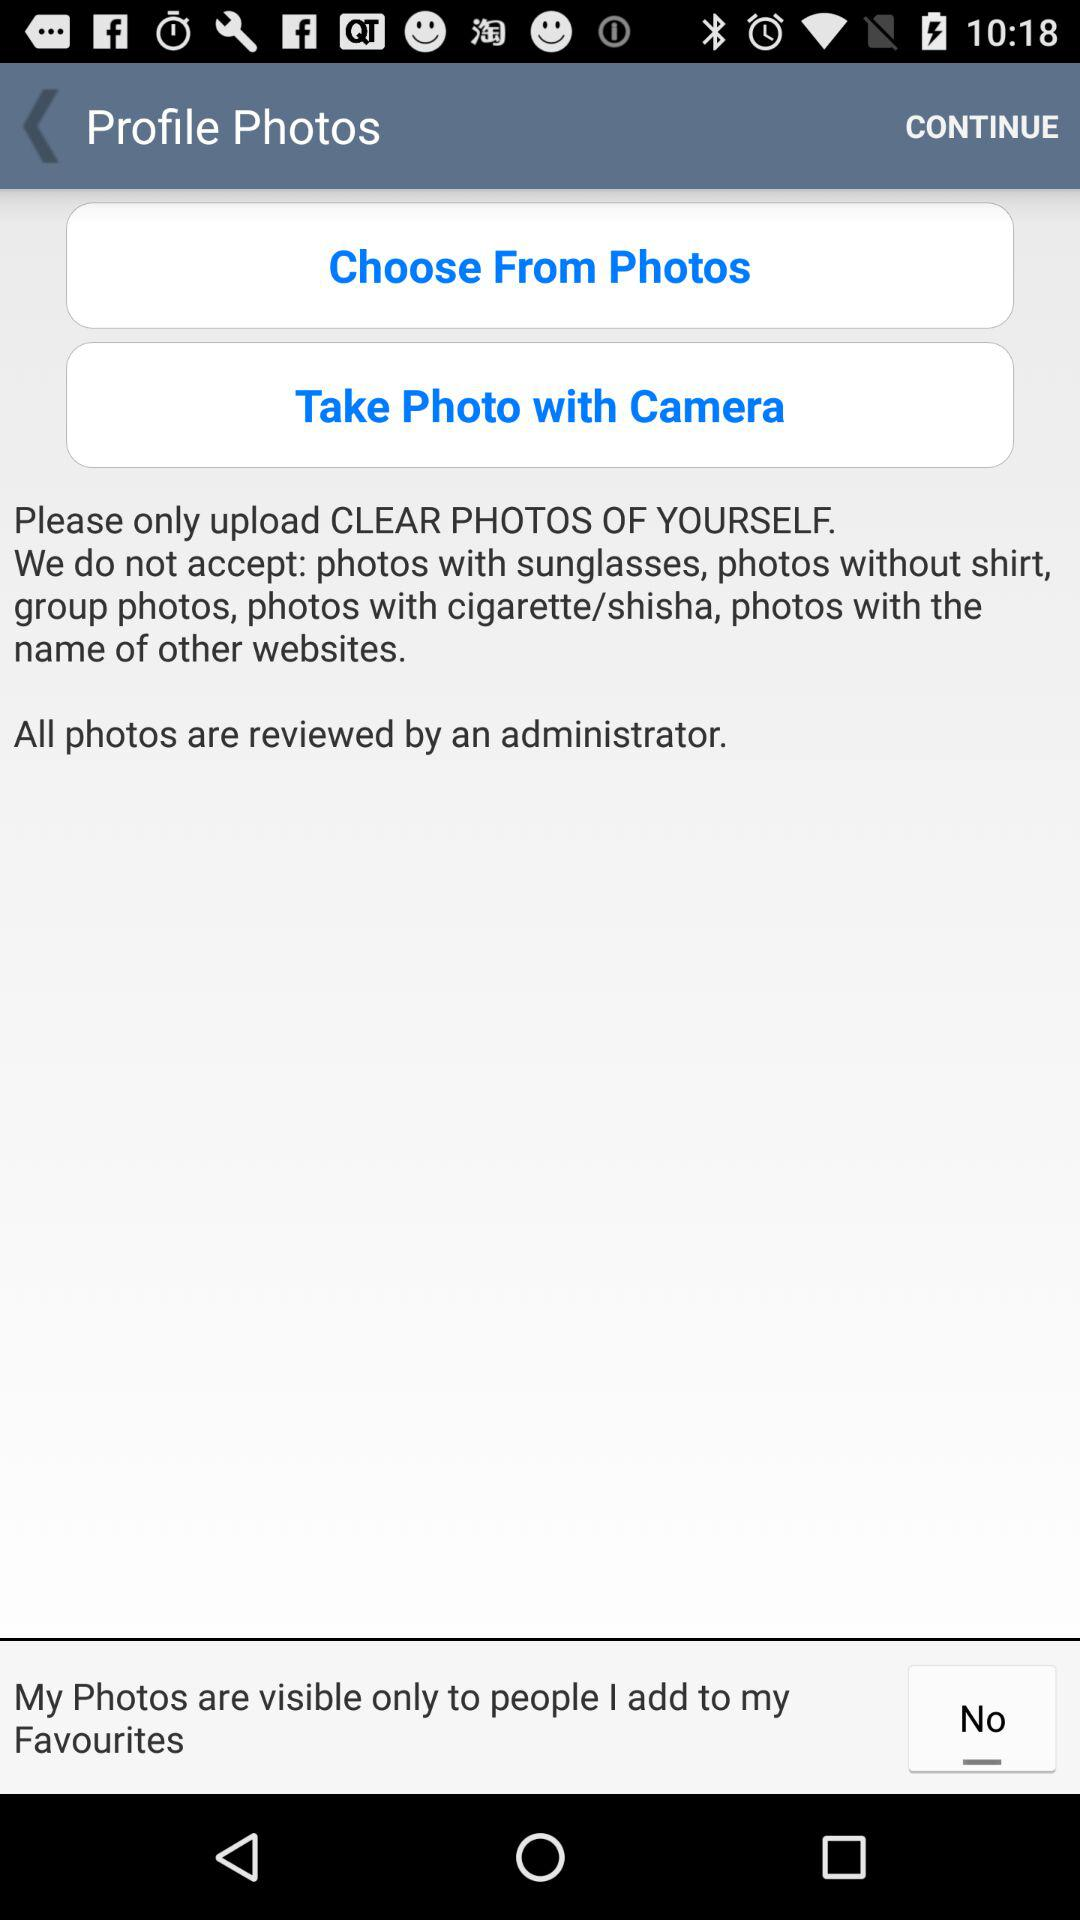How many photos can be uploaded?
When the provided information is insufficient, respond with <no answer>. <no answer> 